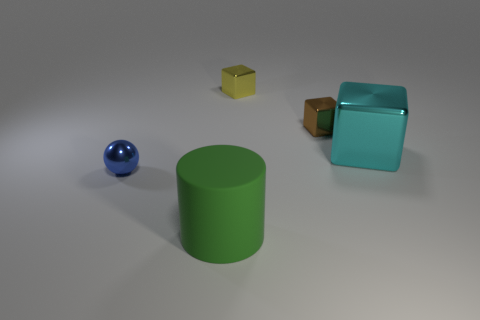There is a yellow object; is its shape the same as the cyan metal thing behind the big green matte thing?
Keep it short and to the point. Yes. How many other cubes are the same size as the brown block?
Provide a short and direct response. 1. There is a thing that is in front of the small object in front of the large cyan metallic block; how many cyan metal blocks are on the left side of it?
Your answer should be very brief. 0. Are there an equal number of large things that are behind the small blue thing and cylinders left of the green rubber cylinder?
Your answer should be very brief. No. What number of blue shiny things have the same shape as the small brown thing?
Your response must be concise. 0. Is there a small blue thing that has the same material as the brown object?
Offer a terse response. Yes. What number of tiny matte blocks are there?
Give a very brief answer. 0. How many balls are blue objects or tiny brown things?
Offer a terse response. 1. There is a object that is the same size as the green matte cylinder; what is its color?
Give a very brief answer. Cyan. What number of small metallic things are both in front of the yellow block and behind the blue shiny sphere?
Provide a short and direct response. 1. 